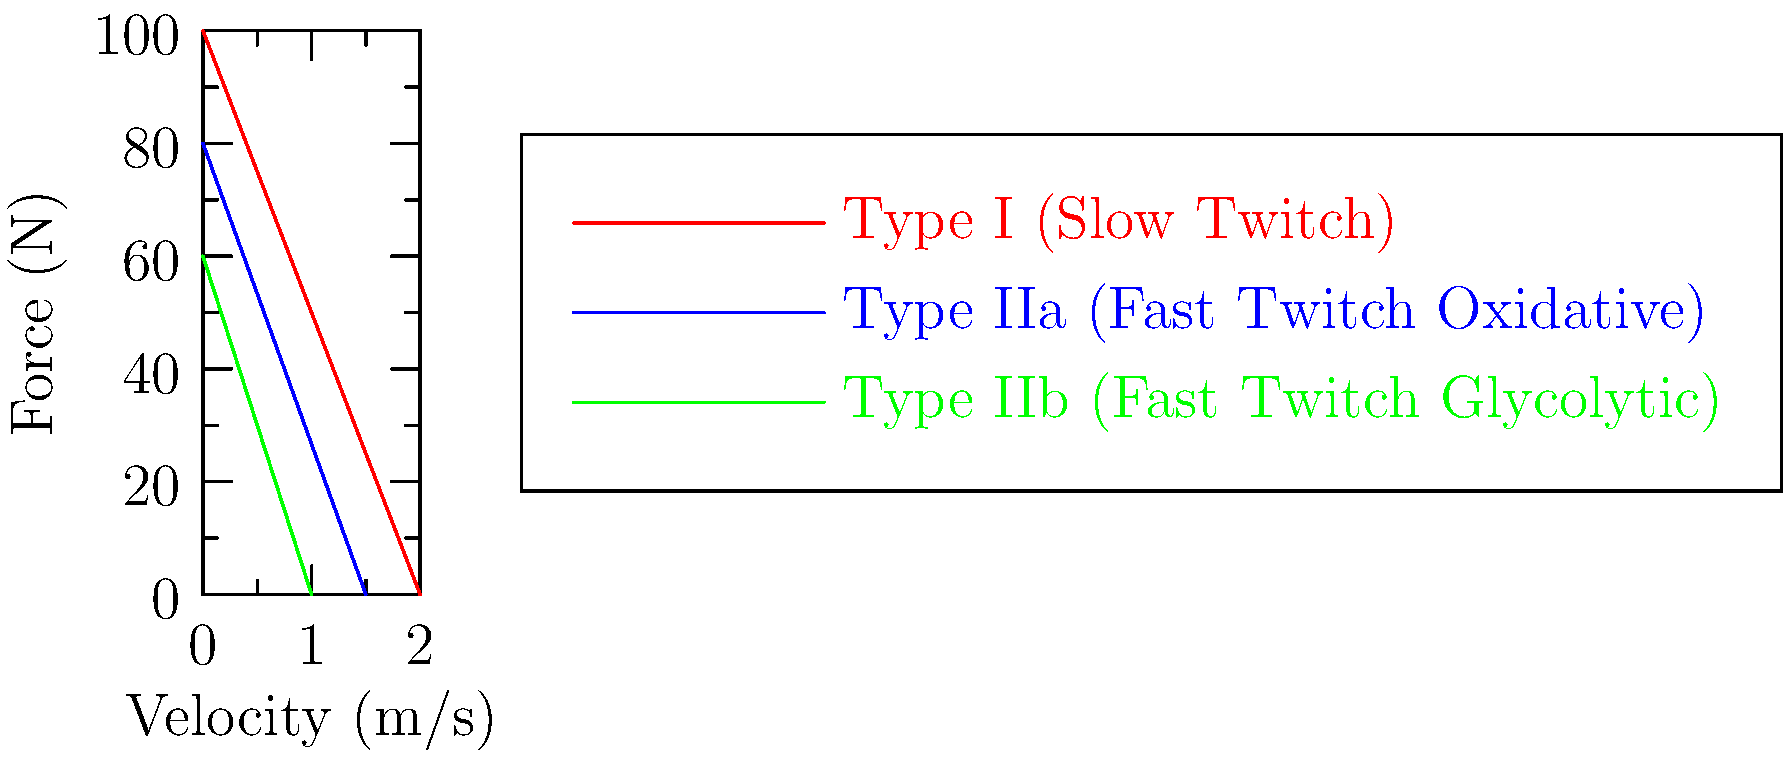As a technology strategist aligning IT initiatives with business goals, you're working on a project involving biomechanical data analysis. You encounter a graph showing force-velocity curves for different muscle fiber types. Based on the graph, which muscle fiber type exhibits the highest maximum force output but the lowest maximum velocity? To answer this question, we need to analyze the force-velocity curves for each muscle fiber type:

1. Identify the three curves:
   - Red: Type I (Slow Twitch)
   - Blue: Type IIa (Fast Twitch Oxidative)
   - Green: Type IIb (Fast Twitch Glycolytic)

2. Compare maximum force output:
   - The y-intercept represents the maximum force at zero velocity.
   - Type I (red) has the highest y-intercept at approximately 100 N.
   - Type IIa (blue) is second at about 80 N.
   - Type IIb (green) has the lowest at around 60 N.

3. Compare maximum velocity:
   - The x-intercept represents the maximum velocity at zero force.
   - Type I (red) has the highest x-intercept at 2 m/s.
   - Type IIa (blue) is second at 1.5 m/s.
   - Type IIb (green) has the lowest at 1 m/s.

4. Identify the muscle fiber type that meets both criteria:
   - Highest maximum force output: Type I (red)
   - Lowest maximum velocity: Type IIb (green)

5. Conclusion:
   Type I (Slow Twitch) muscle fibers exhibit the highest maximum force output but the lowest maximum velocity among the three types shown.

This analysis demonstrates how different muscle fiber types are optimized for various functions, which can be crucial in designing biomechanical systems or analyzing athletic performance data.
Answer: Type I (Slow Twitch) muscle fibers 